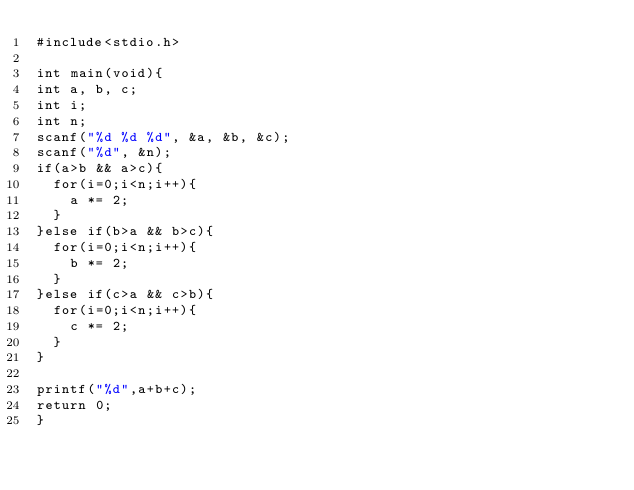Convert code to text. <code><loc_0><loc_0><loc_500><loc_500><_C_>#include<stdio.h>
 
int main(void){
int a, b, c;
int i;
int n;
scanf("%d %d %d", &a, &b, &c);
scanf("%d", &n);
if(a>b && a>c){
  for(i=0;i<n;i++){
    a *= 2;
  }
}else if(b>a && b>c){
  for(i=0;i<n;i++){
    b *= 2;
  }
}else if(c>a && c>b){
  for(i=0;i<n;i++){
    c *= 2;
  }
}

printf("%d",a+b+c);
return 0;
}</code> 